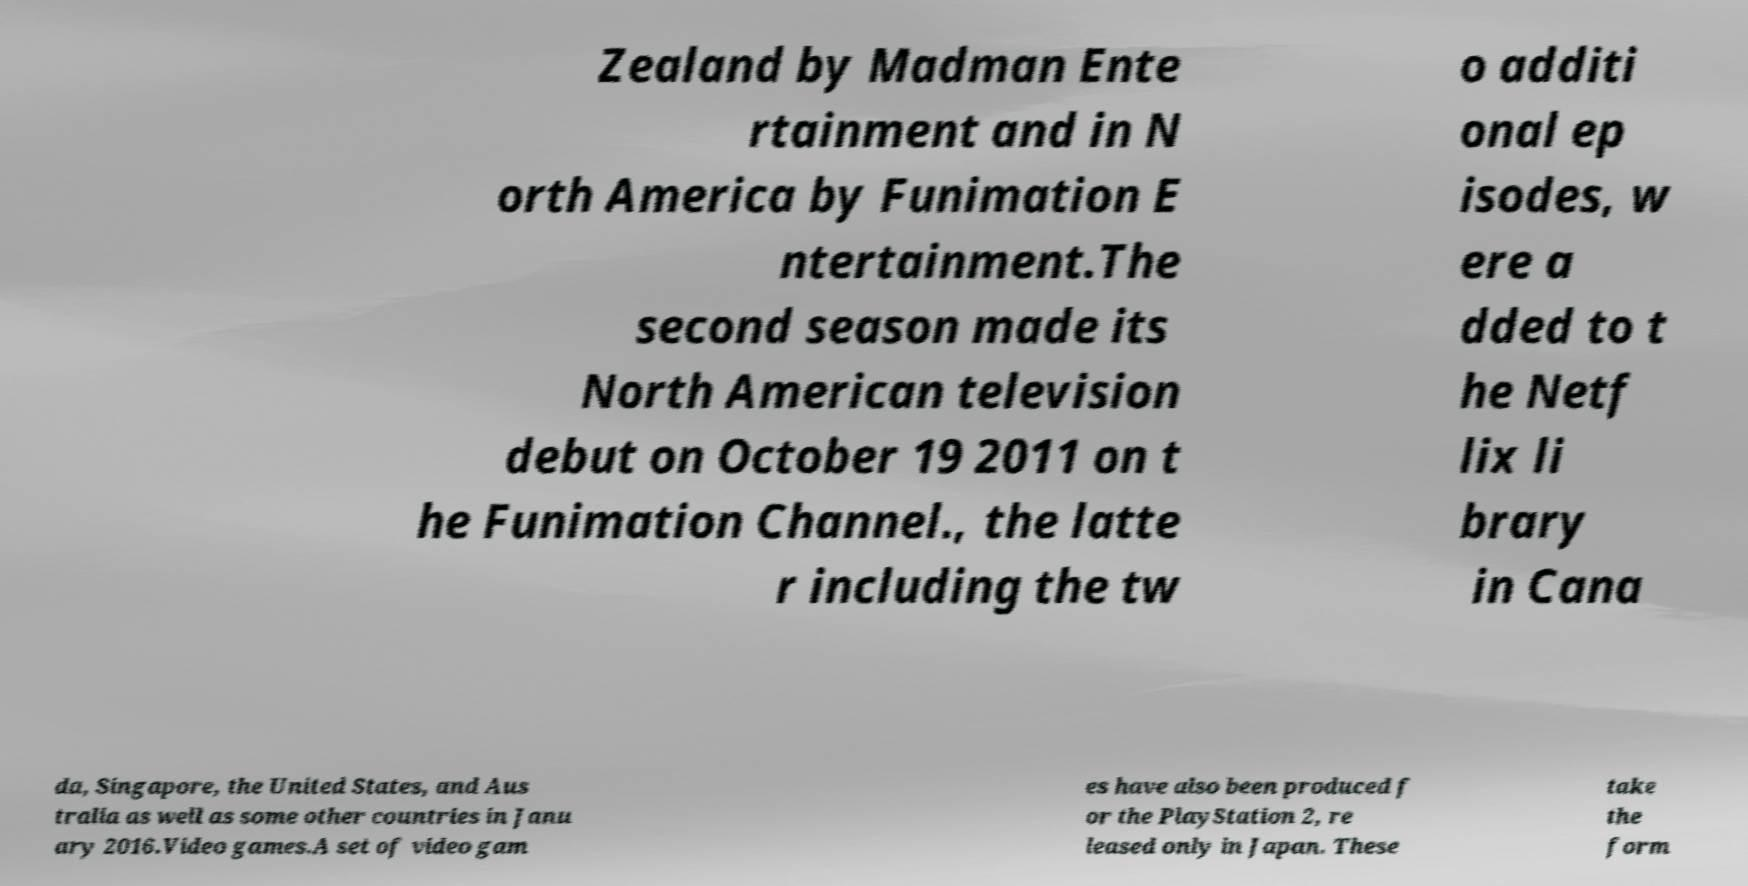For documentation purposes, I need the text within this image transcribed. Could you provide that? Zealand by Madman Ente rtainment and in N orth America by Funimation E ntertainment.The second season made its North American television debut on October 19 2011 on t he Funimation Channel., the latte r including the tw o additi onal ep isodes, w ere a dded to t he Netf lix li brary in Cana da, Singapore, the United States, and Aus tralia as well as some other countries in Janu ary 2016.Video games.A set of video gam es have also been produced f or the PlayStation 2, re leased only in Japan. These take the form 